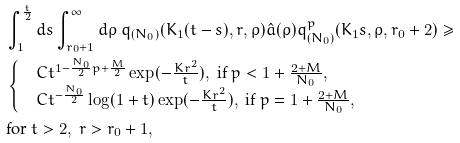Convert formula to latex. <formula><loc_0><loc_0><loc_500><loc_500>& \int _ { 1 } ^ { \frac { t } { 2 } } d s \int _ { r _ { 0 } + 1 } ^ { \infty } d \rho \ q _ { ( N _ { 0 } ) } ( K _ { 1 } ( t - s ) , r , \rho ) \hat { a } ( \rho ) q ^ { p } _ { ( N _ { 0 } ) } ( K _ { 1 } s , \rho , r _ { 0 } + 2 ) \geq \\ & \begin{cases} & C t ^ { 1 - \frac { N _ { 0 } } 2 p + \frac { M } { 2 } } \exp ( - \frac { K r ^ { 2 } } t ) , \ \text {if} \ p < 1 + \frac { 2 + M } { N _ { 0 } } , \\ & C t ^ { - \frac { N _ { 0 } } 2 } \log ( 1 + t ) \exp ( - \frac { K r ^ { 2 } } t ) , \ \text {if} \ p = 1 + \frac { 2 + M } { N _ { 0 } } , \end{cases} \\ & \text {for} \ t > 2 , \ r > r _ { 0 } + 1 ,</formula> 